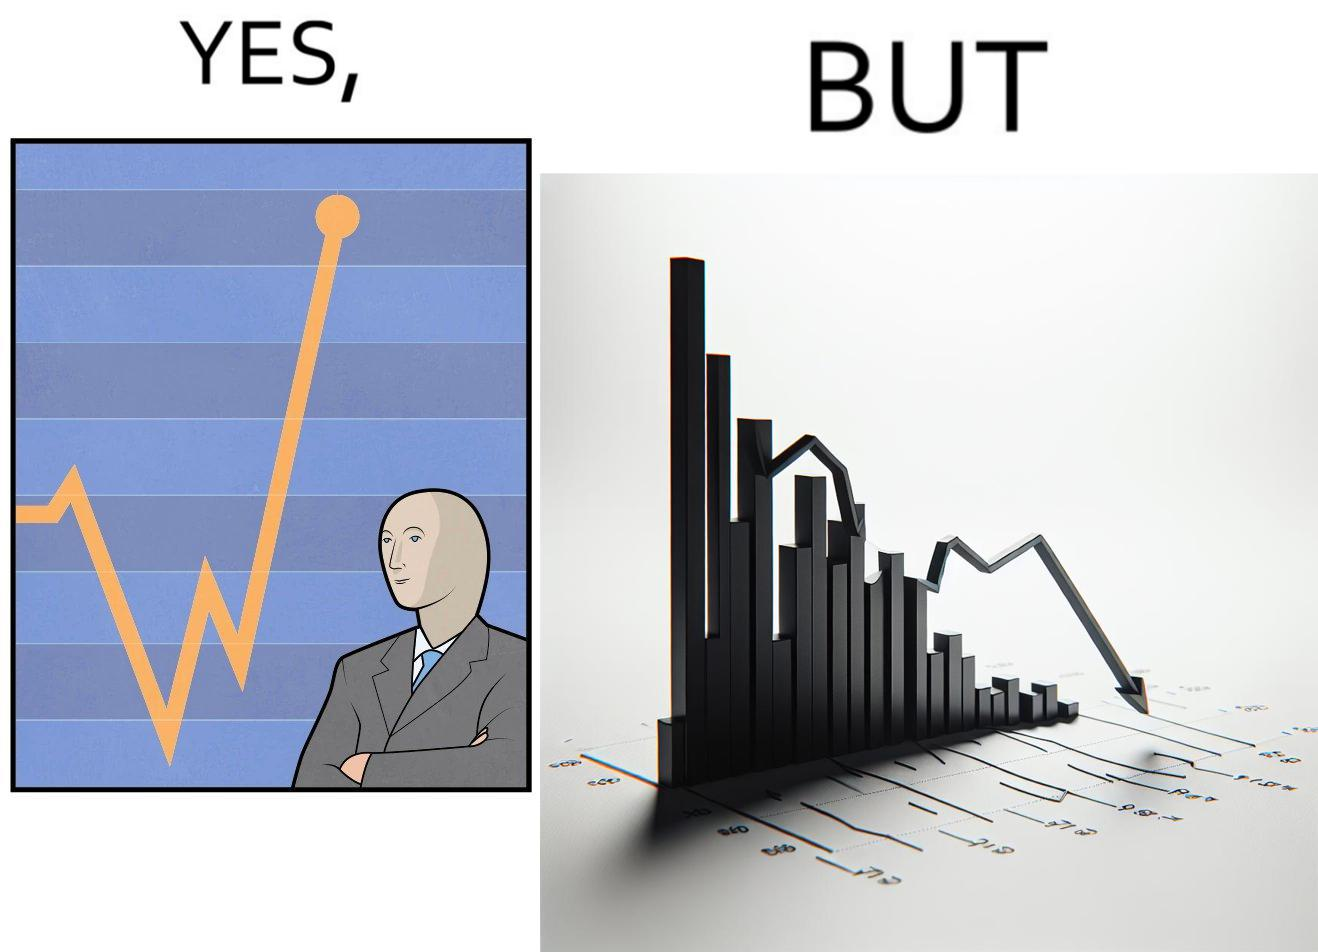Describe the contrast between the left and right parts of this image. In the left part of the image: a person feeling proud after looking at the profit in his stocks investment In the right part of the image: a graph representing loss in some stocks 